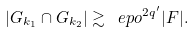<formula> <loc_0><loc_0><loc_500><loc_500>| G _ { k _ { 1 } } \cap G _ { k _ { 2 } } | \gtrsim \ e p o ^ { 2 q ^ { \prime } } | F | .</formula> 